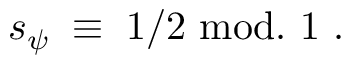Convert formula to latex. <formula><loc_0><loc_0><loc_500><loc_500>s _ { \psi } \, \equiv \, 1 / 2 m o d . 1 .</formula> 